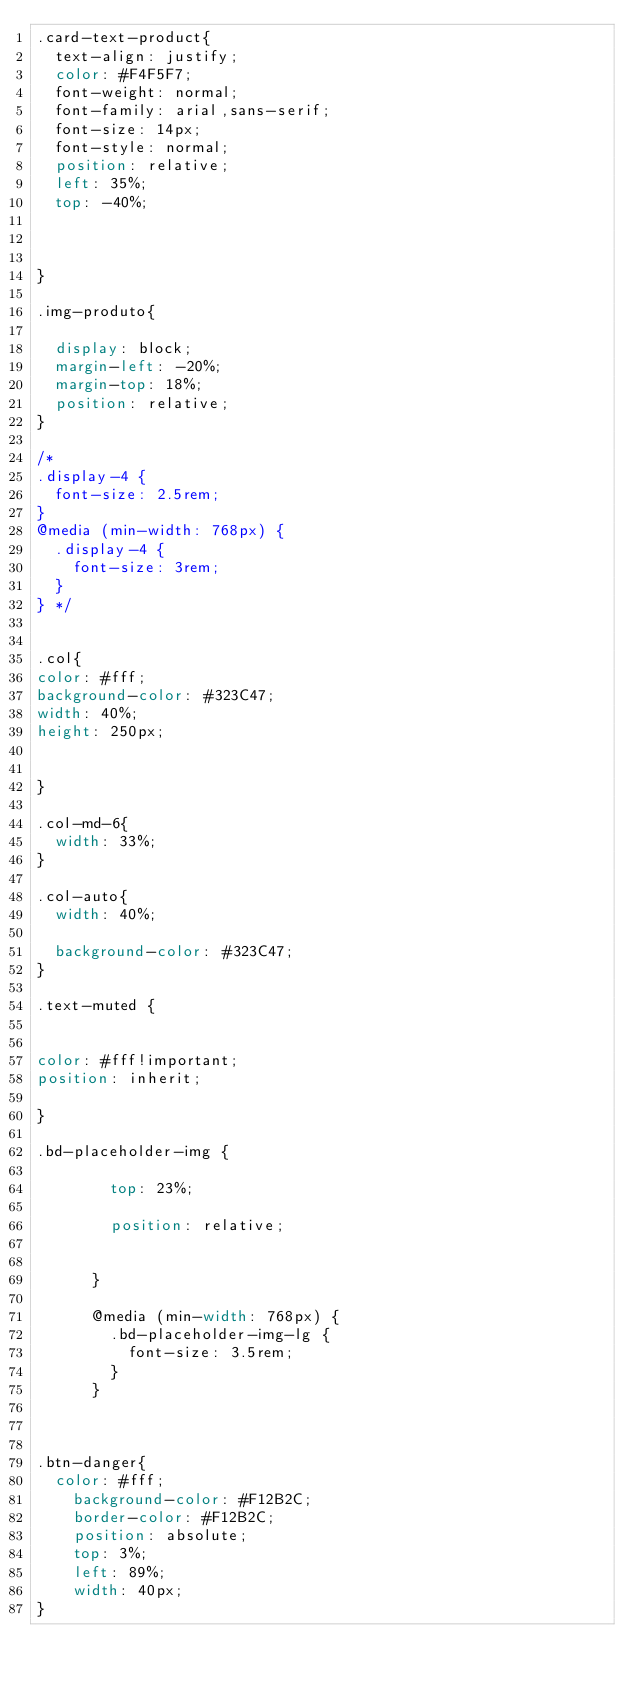Convert code to text. <code><loc_0><loc_0><loc_500><loc_500><_CSS_>.card-text-product{
  text-align: justify;
  color: #F4F5F7;
  font-weight: normal;
  font-family: arial,sans-serif;
  font-size: 14px;
  font-style: normal;
  position: relative;
  left: 35%;
  top: -40%;
  

  
}

.img-produto{

  display: block;
  margin-left: -20%;
  margin-top: 18%;
  position: relative;
}

/*
.display-4 {
  font-size: 2.5rem;
}
@media (min-width: 768px) {
  .display-4 {
    font-size: 3rem;
  }
} */


.col{
color: #fff;
background-color: #323C47;
width: 40%;
height: 250px;


}

.col-md-6{
  width: 33%;
}

.col-auto{
  width: 40%;
  
  background-color: #323C47;
}

.text-muted {


color: #fff!important;
position: inherit;

}

.bd-placeholder-img {
        
        top: 23%;
        
        position: relative;
        

      }

      @media (min-width: 768px) {
        .bd-placeholder-img-lg {
          font-size: 3.5rem;
        }
      }
      
      
      
.btn-danger{
	color: #fff;
    background-color: #F12B2C;
    border-color: #F12B2C;
    position: absolute;
  	top: 3%;
    left: 89%;
    width: 40px;
}</code> 